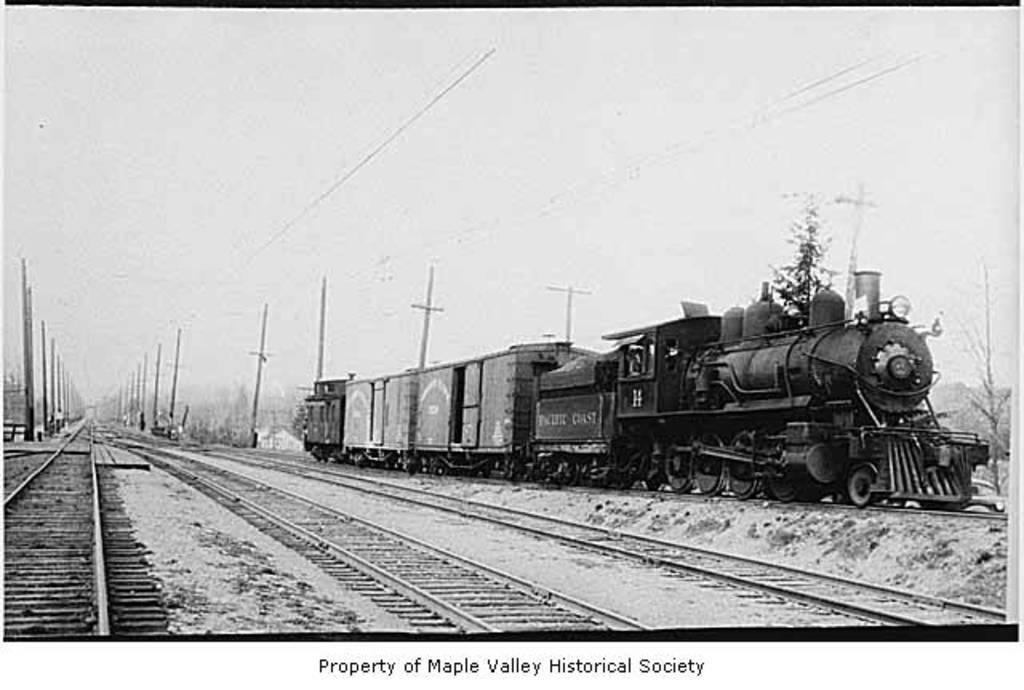What is the main subject of the image? The main subject of the image is a train. Where is the train located in the image? The train is on a railway track. What can be seen in the background of the image? There are poles and the sky visible in the background. What type of trousers is the train wearing in the image? Trains do not wear trousers, as they are inanimate objects. 